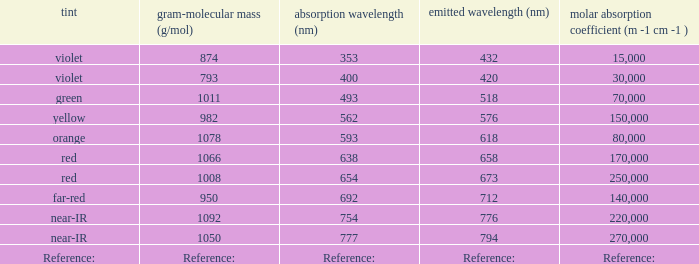Which ε (M -1 cm -1) has a molar mass of 1008 g/mol? 250000.0. 